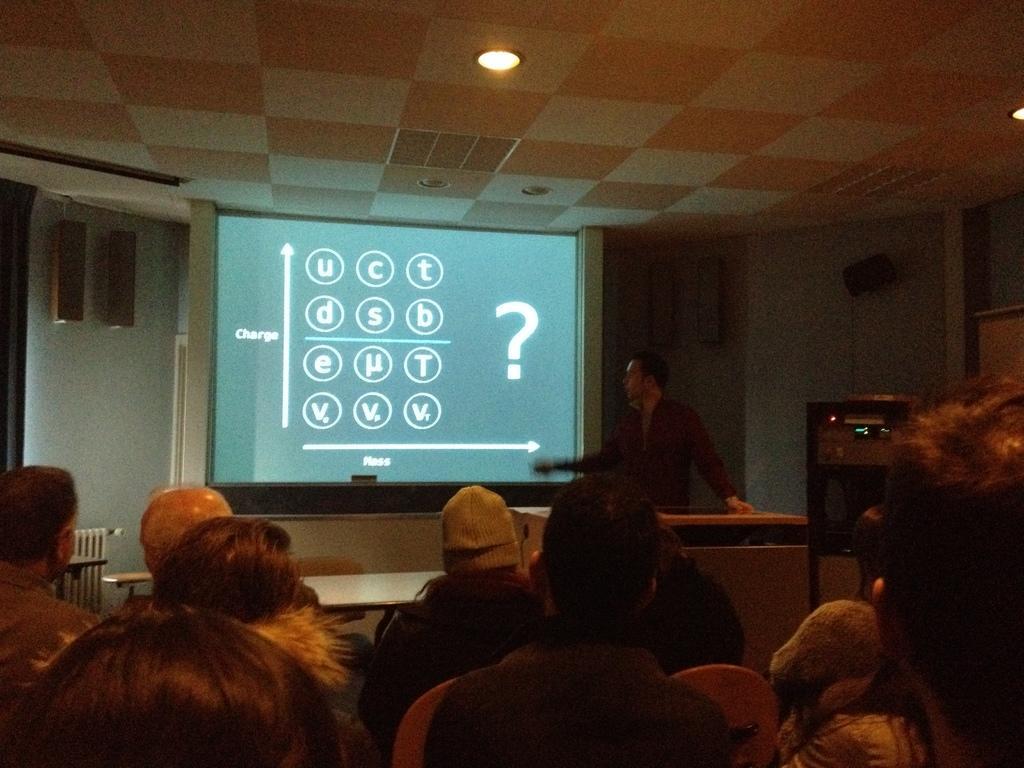In one or two sentences, can you explain what this image depicts? In this image I can see group of people sitting, background I can see the person standing. I can also see the projection screen, a light and the wall is in white color. 